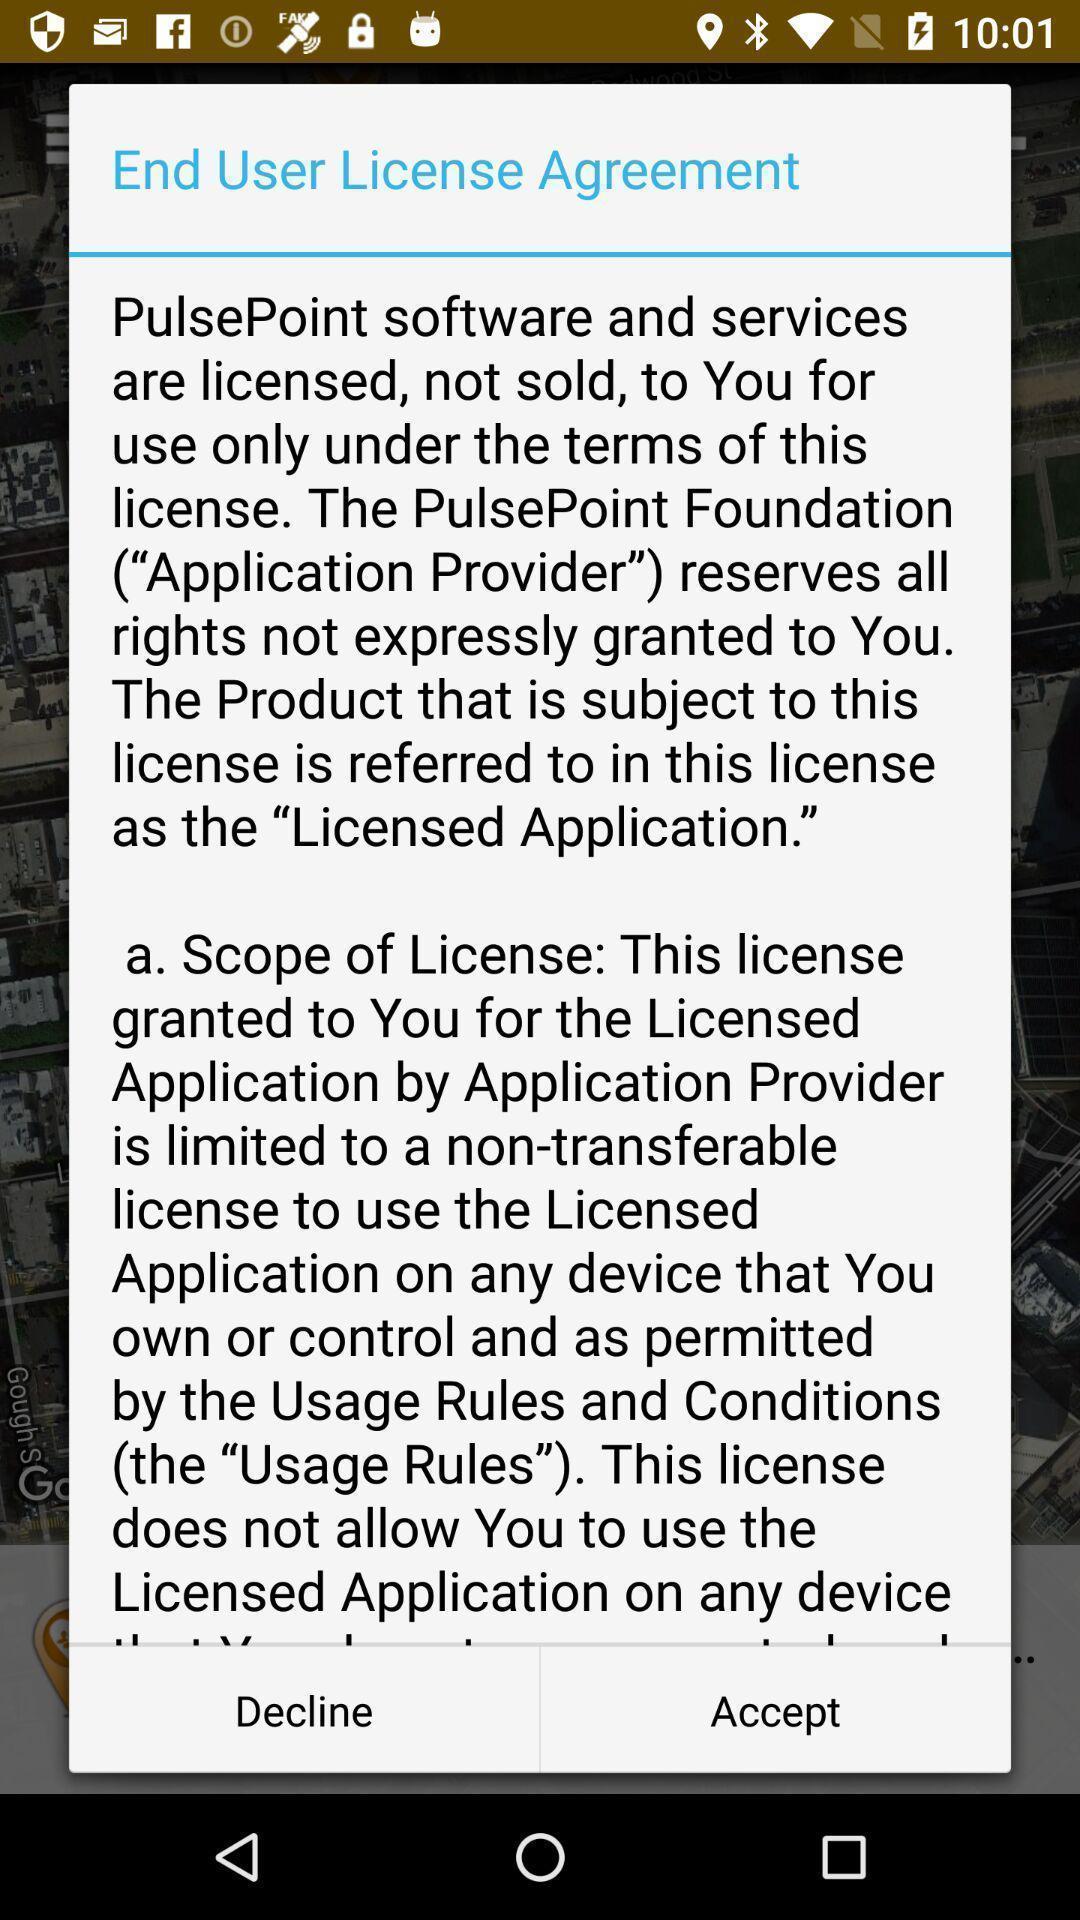Give me a summary of this screen capture. Pop-up screen displaying with information and license agreement. 